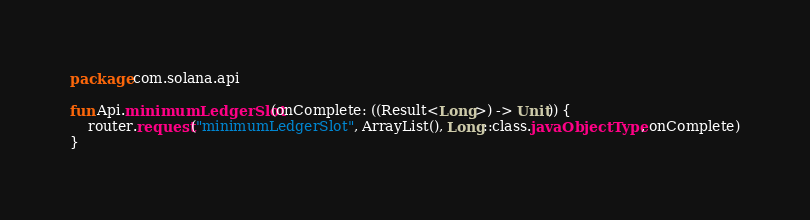Convert code to text. <code><loc_0><loc_0><loc_500><loc_500><_Kotlin_>package com.solana.api

fun Api.minimumLedgerSlot(onComplete: ((Result<Long>) -> Unit)) {
    router.request("minimumLedgerSlot", ArrayList(), Long::class.javaObjectType, onComplete)
}</code> 